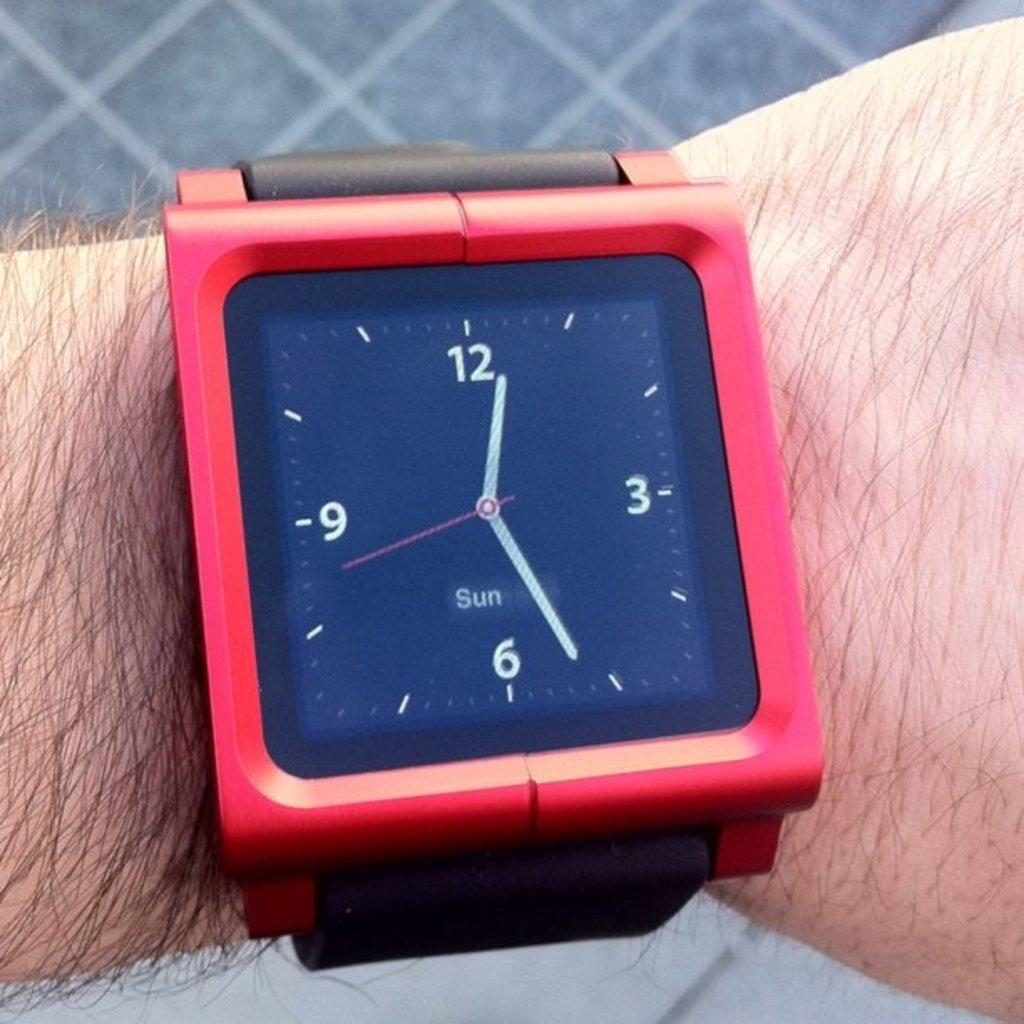<image>
Offer a succinct explanation of the picture presented. A man wearing a smartwatch that says Sun. 